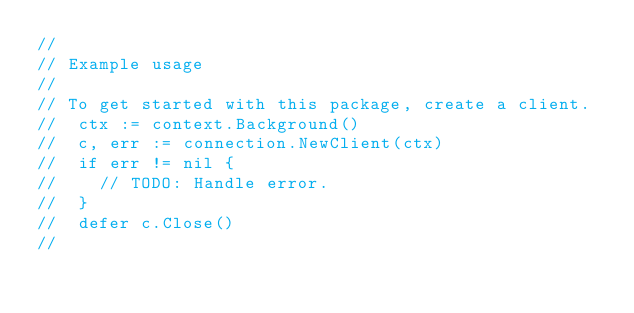<code> <loc_0><loc_0><loc_500><loc_500><_Go_>//
// Example usage
//
// To get started with this package, create a client.
//  ctx := context.Background()
//  c, err := connection.NewClient(ctx)
//  if err != nil {
//  	// TODO: Handle error.
//  }
//  defer c.Close()
//</code> 